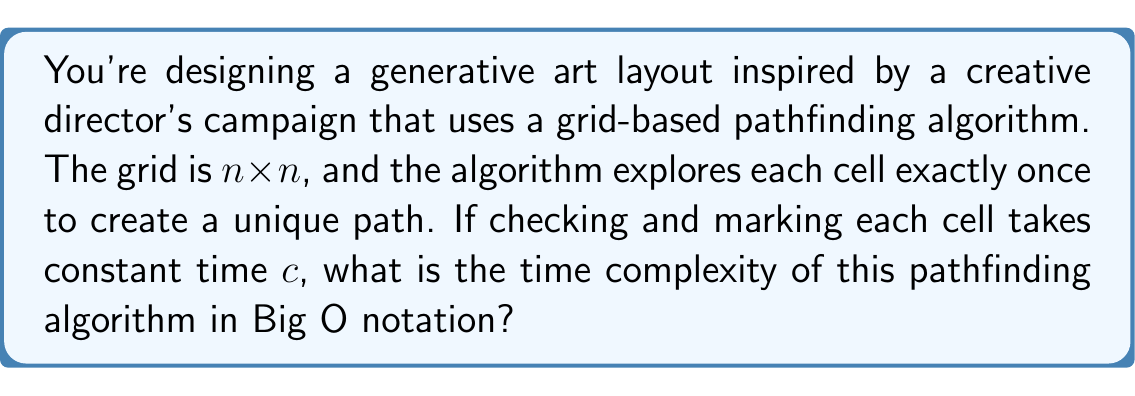Show me your answer to this math problem. To solve this problem, let's break it down step-by-step:

1. Grid size: The grid is $n \times n$, so it contains $n^2$ cells in total.

2. Cell exploration: The algorithm explores each cell exactly once. This means it will perform its operations on all $n^2$ cells.

3. Time per cell: Checking and marking each cell takes constant time $c$.

4. Total time: The total time taken by the algorithm can be expressed as:

   $T(n) = c \cdot n^2$

5. Big O notation: In Big O notation, we focus on the dominant term and disregard constants. In this case:

   $O(T(n)) = O(n^2)$

The constant $c$ is dropped in Big O notation because it doesn't affect the growth rate of the function as $n$ increases.

This quadratic time complexity is typical for algorithms that need to visit every cell in a two-dimensional grid once, which is often the case in grid-based pathfinding or maze-generation algorithms used in generative art.
Answer: $O(n^2)$ 